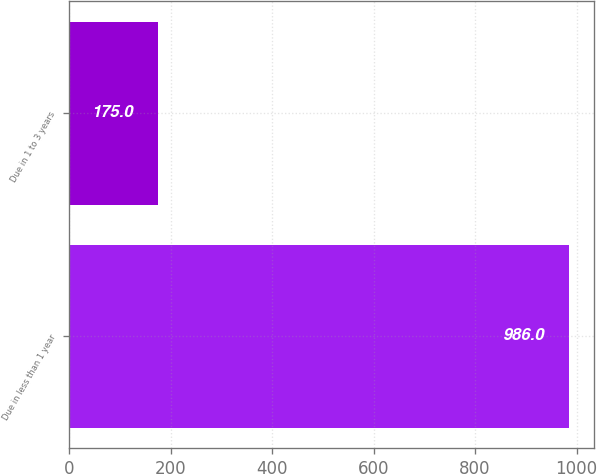Convert chart. <chart><loc_0><loc_0><loc_500><loc_500><bar_chart><fcel>Due in less than 1 year<fcel>Due in 1 to 3 years<nl><fcel>986<fcel>175<nl></chart> 